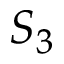<formula> <loc_0><loc_0><loc_500><loc_500>S _ { 3 }</formula> 